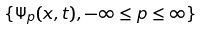Convert formula to latex. <formula><loc_0><loc_0><loc_500><loc_500>\{ \Psi _ { p } ( x , t ) , - \infty \leq p \leq \infty \}</formula> 